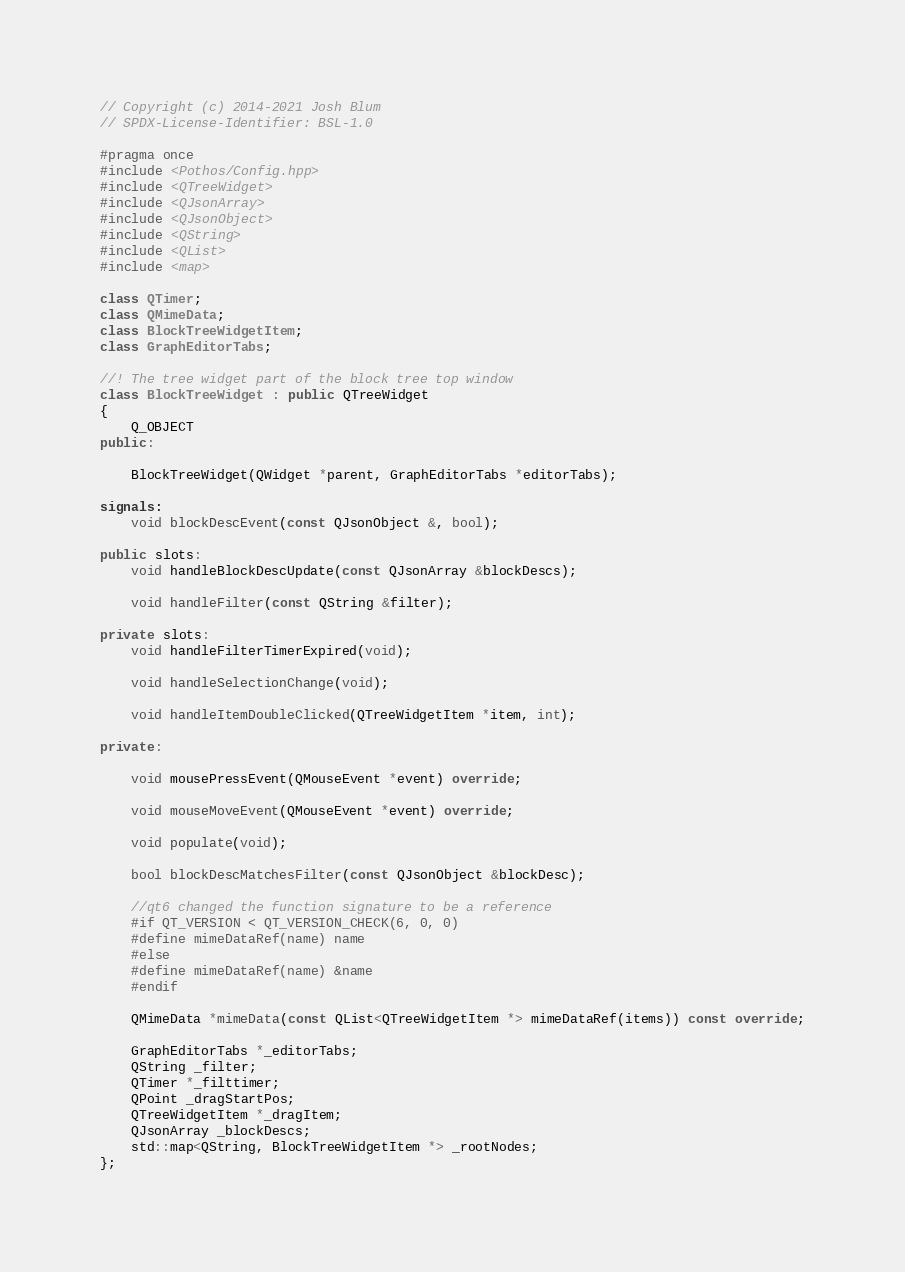Convert code to text. <code><loc_0><loc_0><loc_500><loc_500><_C++_>// Copyright (c) 2014-2021 Josh Blum
// SPDX-License-Identifier: BSL-1.0

#pragma once
#include <Pothos/Config.hpp>
#include <QTreeWidget>
#include <QJsonArray>
#include <QJsonObject>
#include <QString>
#include <QList>
#include <map>

class QTimer;
class QMimeData;
class BlockTreeWidgetItem;
class GraphEditorTabs;

//! The tree widget part of the block tree top window
class BlockTreeWidget : public QTreeWidget
{
    Q_OBJECT
public:

    BlockTreeWidget(QWidget *parent, GraphEditorTabs *editorTabs);

signals:
    void blockDescEvent(const QJsonObject &, bool);

public slots:
    void handleBlockDescUpdate(const QJsonArray &blockDescs);

    void handleFilter(const QString &filter);

private slots:
    void handleFilterTimerExpired(void);

    void handleSelectionChange(void);

    void handleItemDoubleClicked(QTreeWidgetItem *item, int);

private:

    void mousePressEvent(QMouseEvent *event) override;

    void mouseMoveEvent(QMouseEvent *event) override;

    void populate(void);

    bool blockDescMatchesFilter(const QJsonObject &blockDesc);

    //qt6 changed the function signature to be a reference
    #if QT_VERSION < QT_VERSION_CHECK(6, 0, 0)
    #define mimeDataRef(name) name
    #else
    #define mimeDataRef(name) &name
    #endif

    QMimeData *mimeData(const QList<QTreeWidgetItem *> mimeDataRef(items)) const override;

    GraphEditorTabs *_editorTabs;
    QString _filter;
    QTimer *_filttimer;
    QPoint _dragStartPos;
    QTreeWidgetItem *_dragItem;
    QJsonArray _blockDescs;
    std::map<QString, BlockTreeWidgetItem *> _rootNodes;
};
</code> 